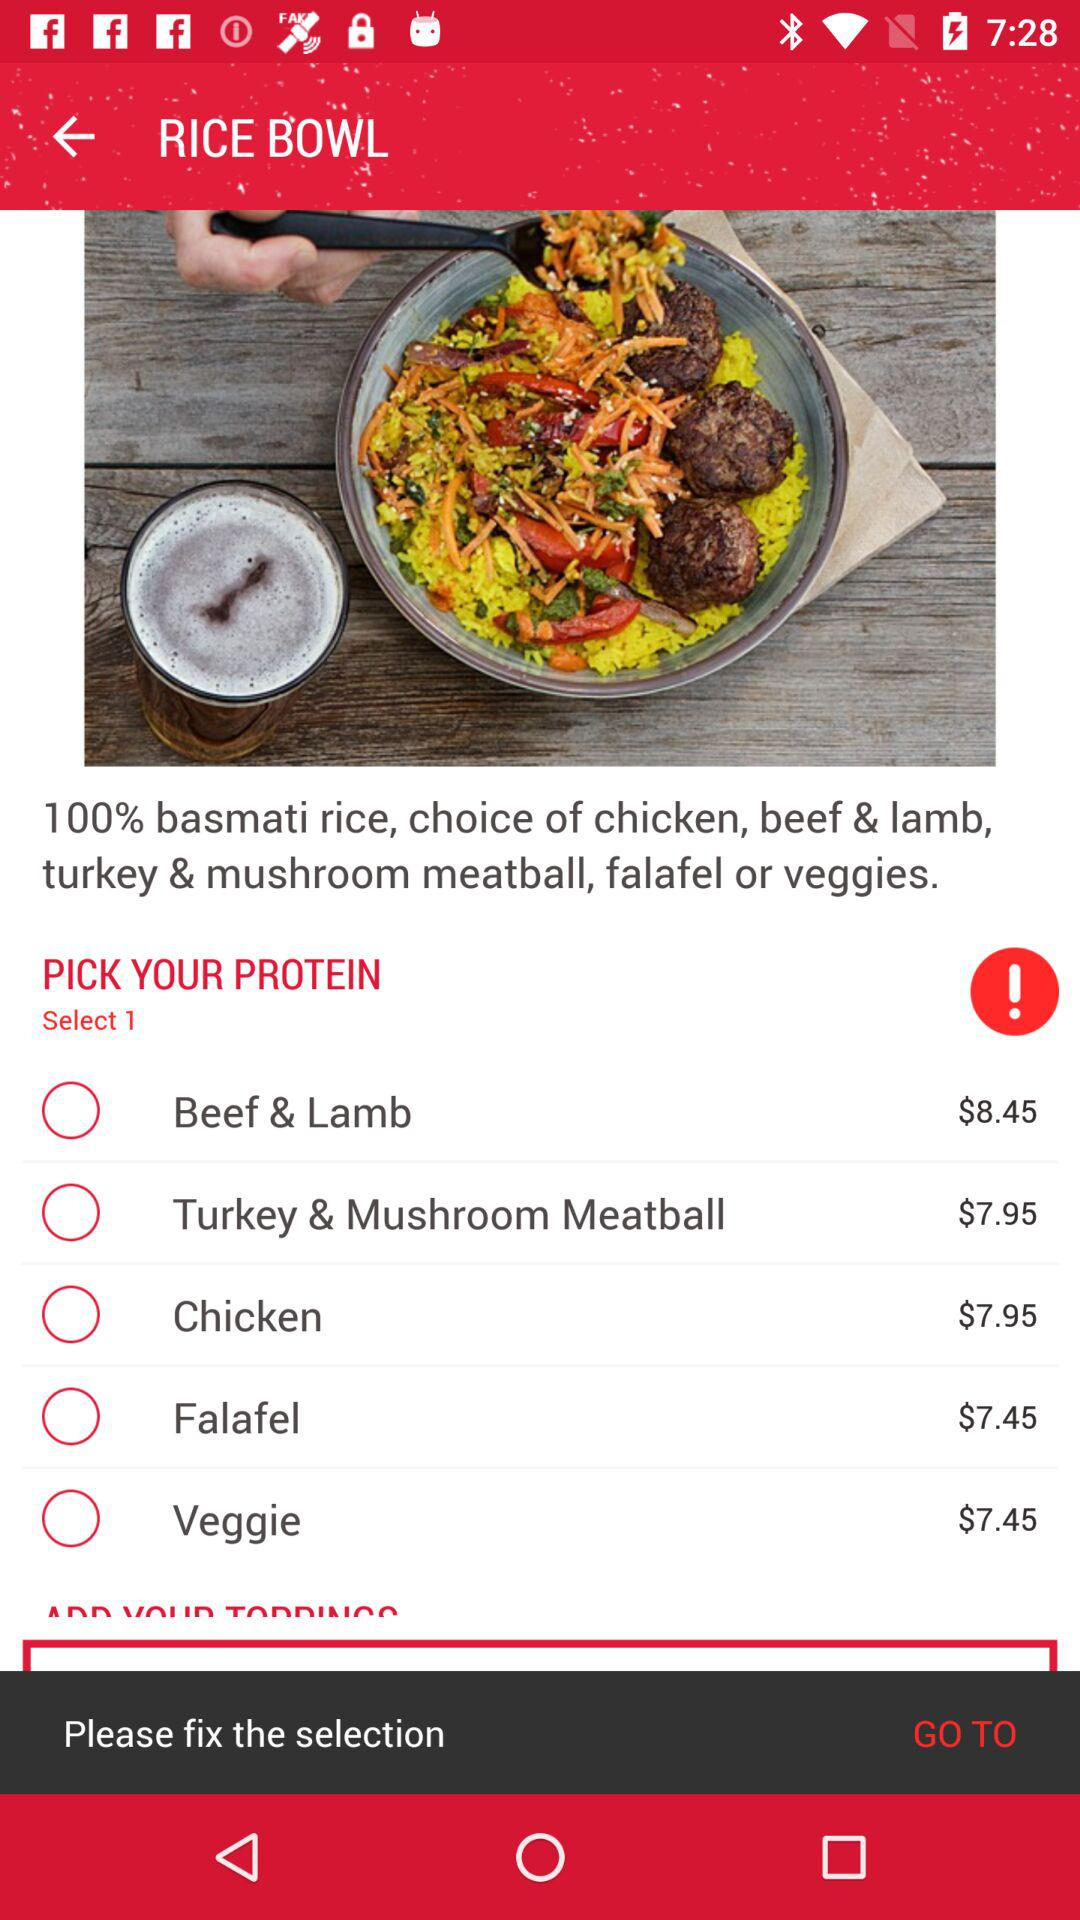What's the cost of "Veggie"? The cost of "Veggie" is $7.45. 